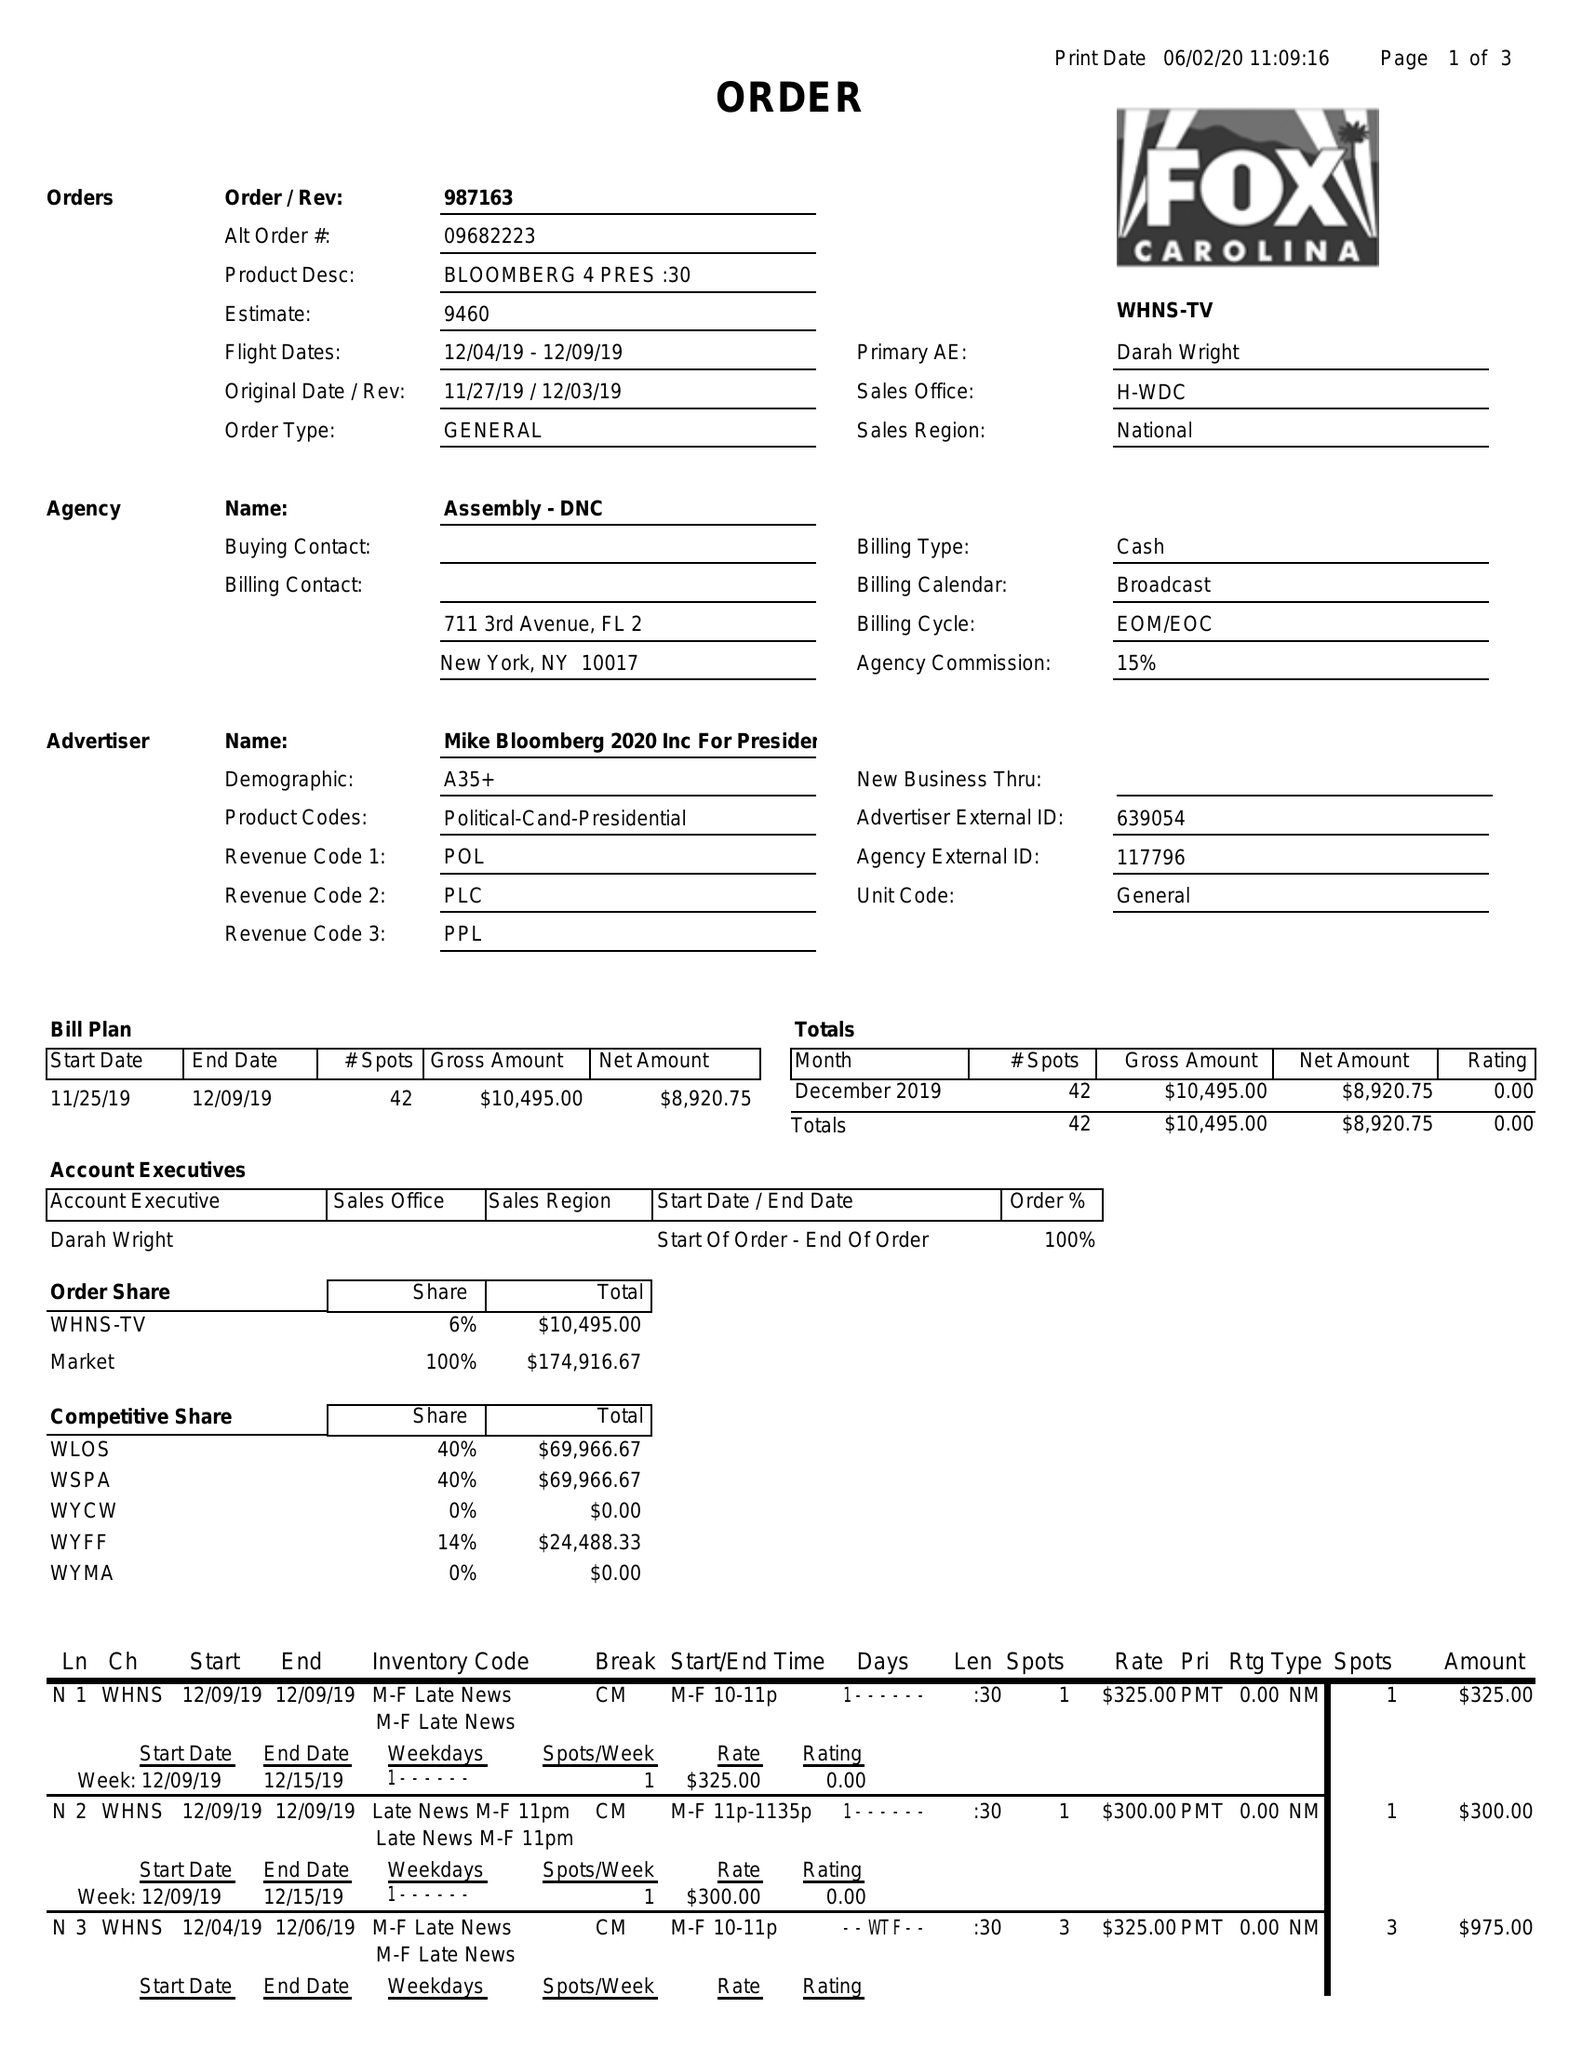What is the value for the contract_num?
Answer the question using a single word or phrase. 987163 